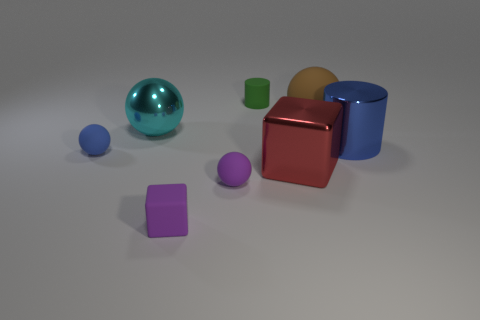How many objects are there in the image? There are seven objects in total: two spheres, three cubes, and two cylinders.  Can you describe the texture of the objects? Certainly. The large sphere and one cylinder have a reflective, glossy finish. The rest of the objects appear to have a matte finish with softer, diffused reflections. 